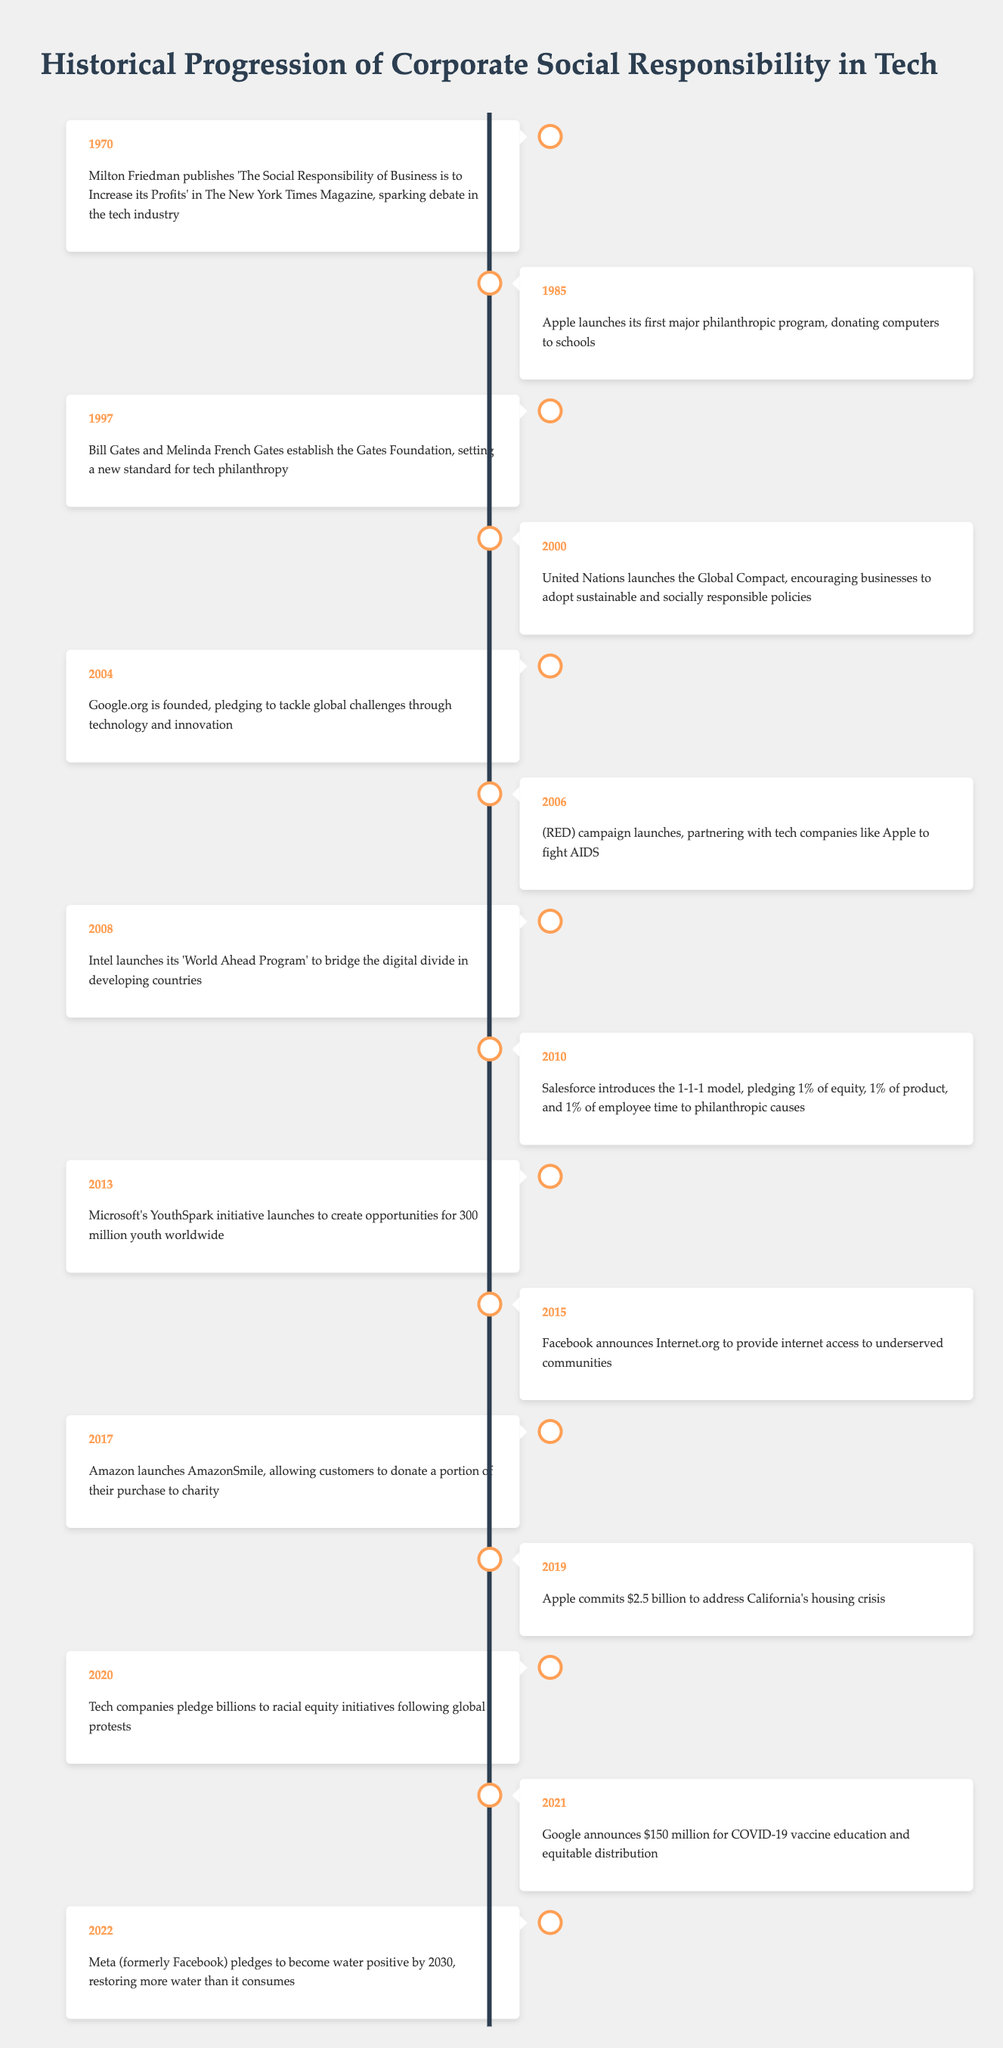What year did Milton Friedman publish his notable article? The timeline indicates that Milton Friedman published 'The Social Responsibility of Business is to Increase its Profits' in 1970. This is the first event listed in the timeline.
Answer: 1970 Which company launched a philanthropic program in 1985? Referring to the 1985 entry in the timeline, it shows that Apple launched its first major philanthropic program that year, donating computers to schools.
Answer: Apple What significant action did Apple take in 2019? The entry for 2019 reports that Apple committed $2.5 billion to address California's housing crisis, marking a major initiative during that time.
Answer: $2.5 billion How many major CSR initiatives are recorded from 2000 to 2020? The timeline lists five initiatives for the years 2000 (UN Global Compact), 2004 (Google.org), 2010 (Salesforce’s 1-1-1 model), 2015 (Facebook’s Internet.org), and 2020 (Tech companies pledge to racial equity). Therefore, five initiatives are noted in that period.
Answer: 5 Did Google announce funding for COVID-19 vaccine education? According to the entry for 2021, Google announced $150 million for COVID-19 vaccine education and equitable distribution, indicating a clear affirmative action by the company.
Answer: Yes Which initiative focused on youth opportunities and when was it launched? The timeline reveals that Microsoft launched the YouthSpark initiative in 2013, aimed at creating opportunities for 300 million youth worldwide. This indicates a targeted focus on youth during that period.
Answer: 2013 What is the chronological order of the first three CSR events listed? By examining the first three entries in the timeline, we find they occur in the years 1970 (Milton Friedman), 1985 (Apple's program), and 1997 (Gates Foundation). This order reflects the sequence of events as they appear in the table.
Answer: 1970, 1985, 1997 What was the focus of Intel's initiative in 2008? The entry for 2008 indicates that Intel launched the 'World Ahead Program' to bridge the digital divide in developing countries, reflecting a focus on technology accessibility and education.
Answer: Digital divide How many years separate Apple's philanthropic program launch and the establishment of the Gates Foundation? The philanthropic program launched in 1985 and the Gates Foundation was established in 1997, which translates to a gap of 12 years between these two events. Calculating this involves simply subtracting the years: 1997 - 1985 = 12.
Answer: 12 years What notable initiative did Meta announce for 2022? In 2022, the timeline indicates that Meta pledged to become water positive by 2030, which requires restoring more water than it consumes, showcasing a commitment to environmental sustainability.
Answer: Water positive by 2030 